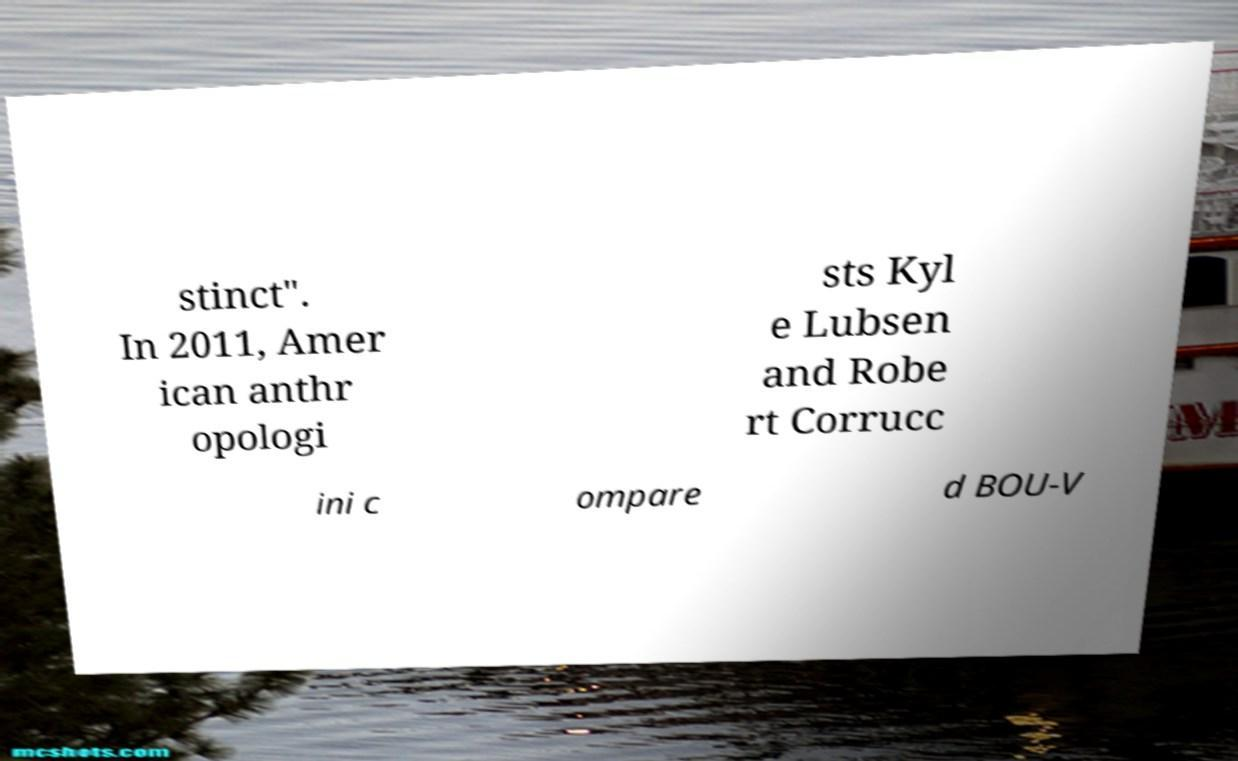Can you accurately transcribe the text from the provided image for me? stinct". In 2011, Amer ican anthr opologi sts Kyl e Lubsen and Robe rt Corrucc ini c ompare d BOU-V 